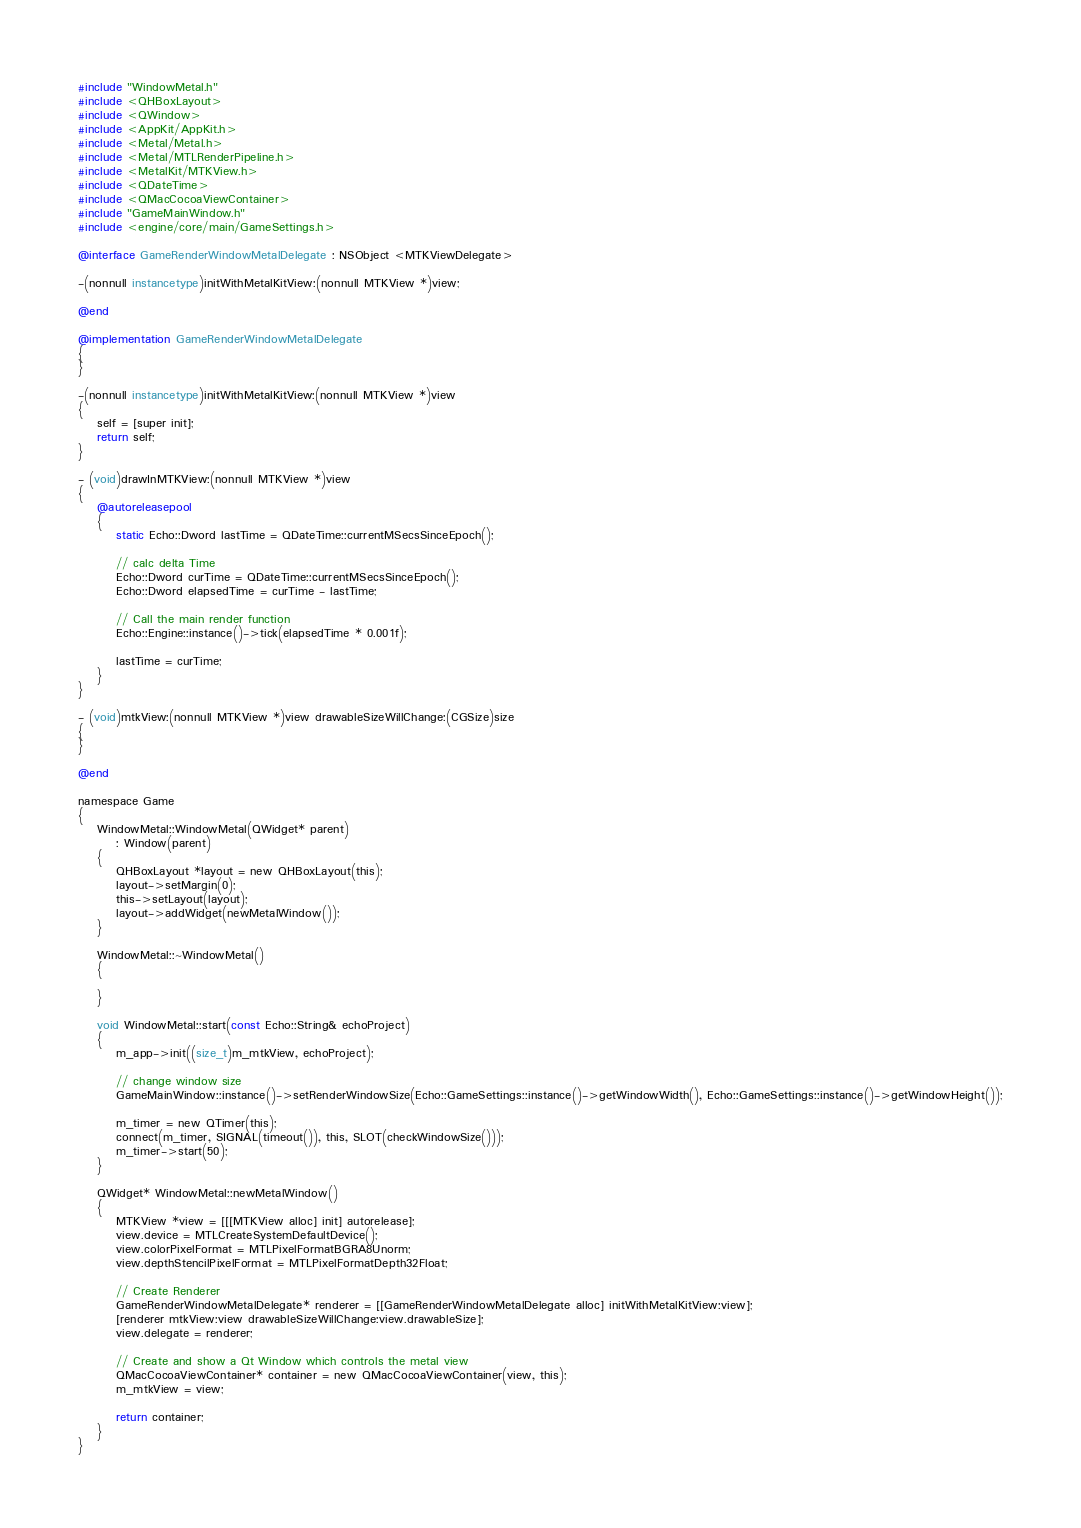Convert code to text. <code><loc_0><loc_0><loc_500><loc_500><_ObjectiveC_>#include "WindowMetal.h"
#include <QHBoxLayout>
#include <QWindow>
#include <AppKit/AppKit.h>
#include <Metal/Metal.h>
#include <Metal/MTLRenderPipeline.h>
#include <MetalKit/MTKView.h>
#include <QDateTime>
#include <QMacCocoaViewContainer>
#include "GameMainWindow.h"
#include <engine/core/main/GameSettings.h>

@interface GameRenderWindowMetalDelegate : NSObject <MTKViewDelegate>

-(nonnull instancetype)initWithMetalKitView:(nonnull MTKView *)view;

@end

@implementation GameRenderWindowMetalDelegate
{
}

-(nonnull instancetype)initWithMetalKitView:(nonnull MTKView *)view
{
    self = [super init];
    return self;
}

- (void)drawInMTKView:(nonnull MTKView *)view
{
    @autoreleasepool
    {
        static Echo::Dword lastTime = QDateTime::currentMSecsSinceEpoch();

        // calc delta Time
        Echo::Dword curTime = QDateTime::currentMSecsSinceEpoch();
        Echo::Dword elapsedTime = curTime - lastTime;

        // Call the main render function
        Echo::Engine::instance()->tick(elapsedTime * 0.001f);

        lastTime = curTime;
    }
}

- (void)mtkView:(nonnull MTKView *)view drawableSizeWillChange:(CGSize)size
{
}

@end

namespace Game
{
    WindowMetal::WindowMetal(QWidget* parent)
        : Window(parent)
    {
        QHBoxLayout *layout = new QHBoxLayout(this);
        layout->setMargin(0);
        this->setLayout(layout);
        layout->addWidget(newMetalWindow());
    }

    WindowMetal::~WindowMetal()
    {
        
    }

    void WindowMetal::start(const Echo::String& echoProject)
    {
        m_app->init((size_t)m_mtkView, echoProject);

        // change window size
        GameMainWindow::instance()->setRenderWindowSize(Echo::GameSettings::instance()->getWindowWidth(), Echo::GameSettings::instance()->getWindowHeight());

        m_timer = new QTimer(this);
        connect(m_timer, SIGNAL(timeout()), this, SLOT(checkWindowSize()));
        m_timer->start(50);
    }

    QWidget* WindowMetal::newMetalWindow()
    {
        MTKView *view = [[[MTKView alloc] init] autorelease];
        view.device = MTLCreateSystemDefaultDevice();
        view.colorPixelFormat = MTLPixelFormatBGRA8Unorm;
        view.depthStencilPixelFormat = MTLPixelFormatDepth32Float;
        
        // Create Renderer
        GameRenderWindowMetalDelegate* renderer = [[GameRenderWindowMetalDelegate alloc] initWithMetalKitView:view];
        [renderer mtkView:view drawableSizeWillChange:view.drawableSize];
        view.delegate = renderer;

        // Create and show a Qt Window which controls the metal view
        QMacCocoaViewContainer* container = new QMacCocoaViewContainer(view, this);
        m_mtkView = view;
        
        return container;
    }
}
</code> 